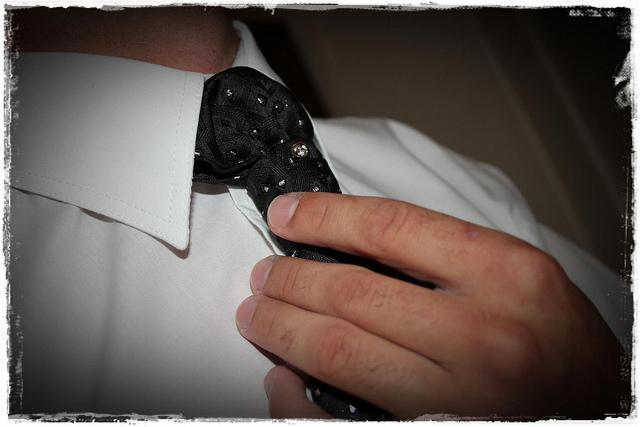How many people are there?
Give a very brief answer. 1. How many keyboards are on the desk?
Give a very brief answer. 0. 